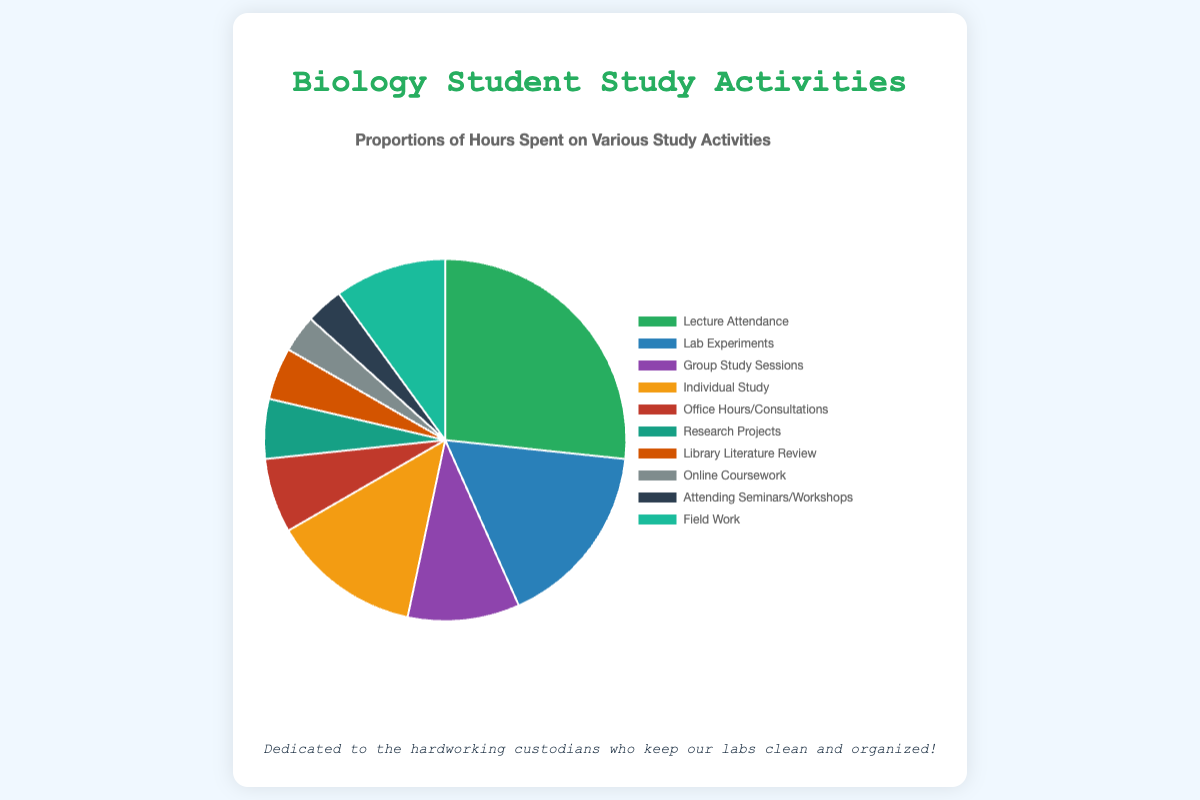Which study activity takes up the largest proportion of biology students' study time? Observing the pie chart, the largest segment is for 'Lecture Attendance'.
Answer: Lecture Attendance How many hours are spent on activities outside of 'Lecture Attendance' and 'Lab Experiments'? To calculate this, subtract the sum of hours spent on 'Lecture Attendance' and 'Lab Experiments' from the total hours. Total hours = 150. Hours on 'Lecture Attendance' = 40, hours on 'Lab Experiments' = 25. So, it's 150 - 40 - 25 = 85 hours.
Answer: 85 hours Which study activity is represented by the light blue segment? The light blue segment is observed in the pie chart and the legend, matching with 'Lab Experiments'.
Answer: Lab Experiments Are there any study activities that take up an equal amount of time? If yes, which ones? By looking at the pie chart, 'Online Coursework' and 'Attending Seminars/Workshops' both have equal segments, each representing 5 hours.
Answer: Online Coursework and Attending Seminars/Workshops How many more hours are spent on 'Individual Study' compared to 'Research Projects'? Refer to the hours on individual activities, 'Individual Study' = 20 hours and 'Research Projects' = 8 hours. The difference is 20 - 8 = 12 hours.
Answer: 12 hours Which activity contributes the least to the study time, and how many hours is that? By identifying the smallest segment in the pie chart, 'Online Coursework' and 'Attending Seminars/Workshops' both have the least hours, each 5 hours.
Answer: Online Coursework and Attending Seminars/Workshops, 5 hours each What is the ratio of hours spent on 'Group Study Sessions' to 'Field Work'? Hours on 'Group Study Sessions' = 15, hours on 'Field Work' = 15, hence the ratio is 15:15 or 1:1.
Answer: 1:1 How many hours are spent on 'Library Literature Review' and 'Office Hours/Consultations' combined? Adding hours of 'Library Literature Review' = 7 and 'Office Hours/Consultations' = 10, 7 + 10 = 17 hours.
Answer: 17 hours Which activity is represented by the yellow segment, and how many hours are spent on it? By locating the yellow segment and matching it with the legend, it corresponds to 'Individual Study' with 20 hours.
Answer: Individual Study, 20 hours 